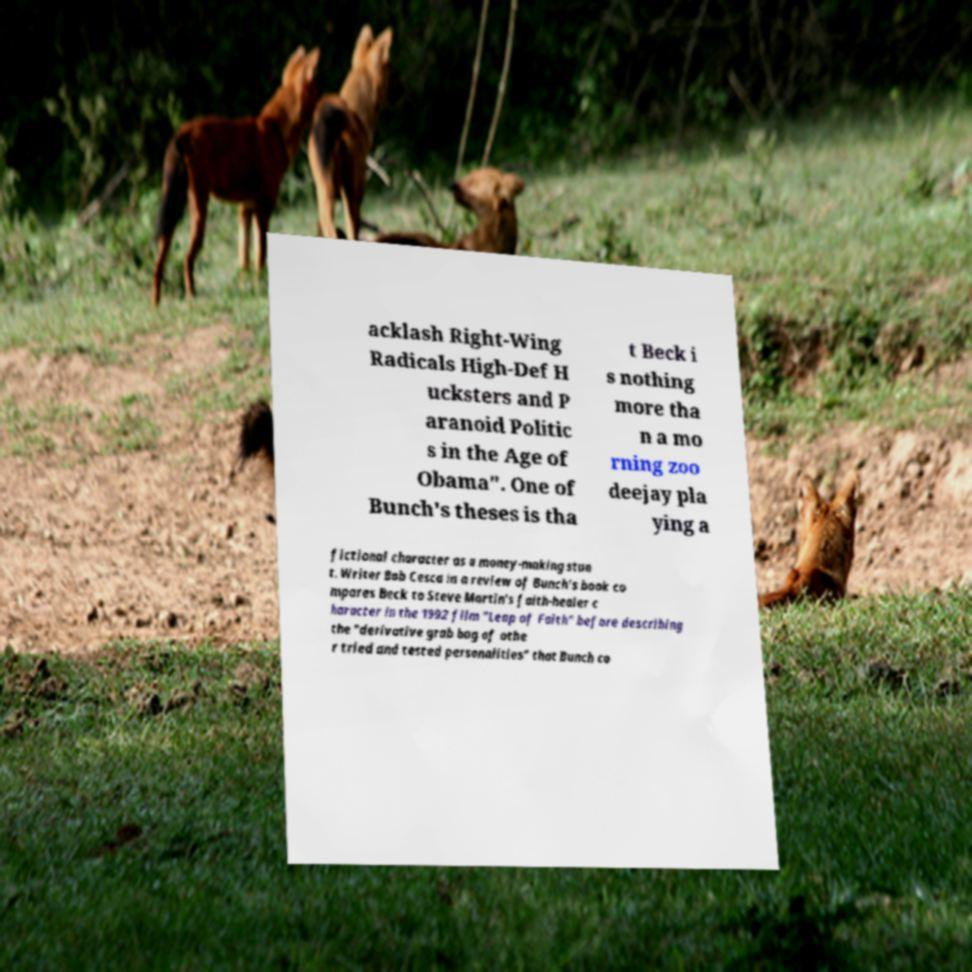Please read and relay the text visible in this image. What does it say? acklash Right-Wing Radicals High-Def H ucksters and P aranoid Politic s in the Age of Obama". One of Bunch's theses is tha t Beck i s nothing more tha n a mo rning zoo deejay pla ying a fictional character as a money-making stun t. Writer Bob Cesca in a review of Bunch's book co mpares Beck to Steve Martin's faith-healer c haracter in the 1992 film "Leap of Faith" before describing the "derivative grab bag of othe r tried and tested personalities" that Bunch co 